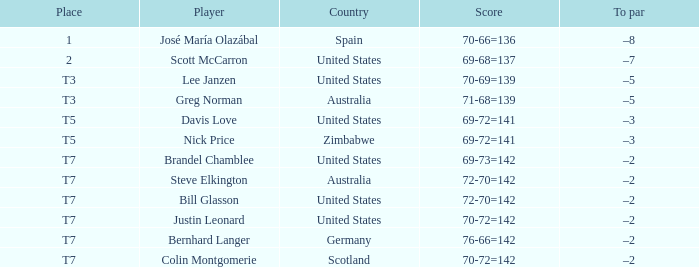WHich Score has a To par of –3, and a Country of united states? 69-72=141. 